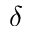Convert formula to latex. <formula><loc_0><loc_0><loc_500><loc_500>\delta</formula> 